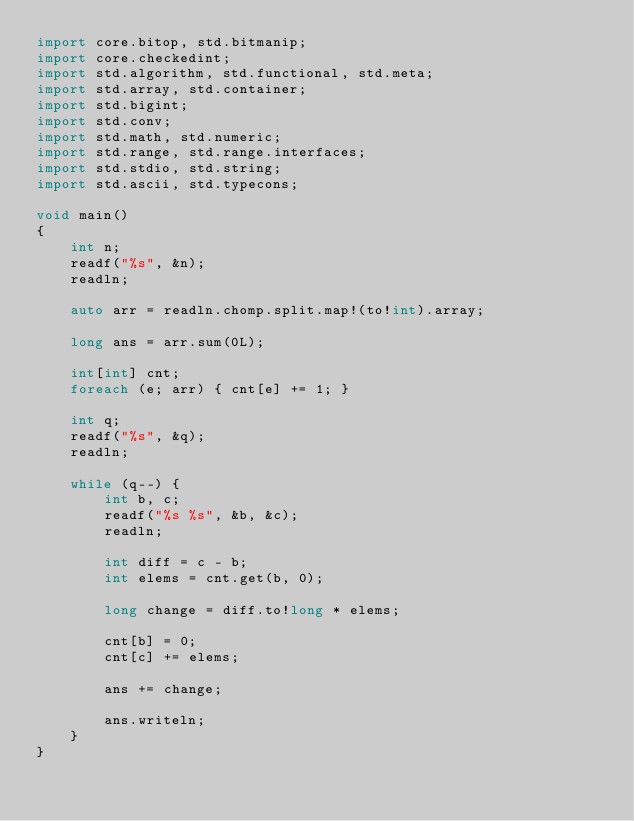<code> <loc_0><loc_0><loc_500><loc_500><_D_>import core.bitop, std.bitmanip;
import core.checkedint;
import std.algorithm, std.functional, std.meta;
import std.array, std.container;
import std.bigint;
import std.conv;
import std.math, std.numeric;
import std.range, std.range.interfaces;
import std.stdio, std.string;
import std.ascii, std.typecons;

void main()
{
    int n;
    readf("%s", &n);
    readln;

    auto arr = readln.chomp.split.map!(to!int).array;
    
    long ans = arr.sum(0L);
    
    int[int] cnt;
    foreach (e; arr) { cnt[e] += 1; }
    
    int q;
    readf("%s", &q);
    readln;
    
    while (q--) {
        int b, c;
        readf("%s %s", &b, &c);
        readln;
        
        int diff = c - b;
        int elems = cnt.get(b, 0);
        
        long change = diff.to!long * elems;
        
        cnt[b] = 0;
        cnt[c] += elems;
        
        ans += change;
        
        ans.writeln;
    }
}</code> 